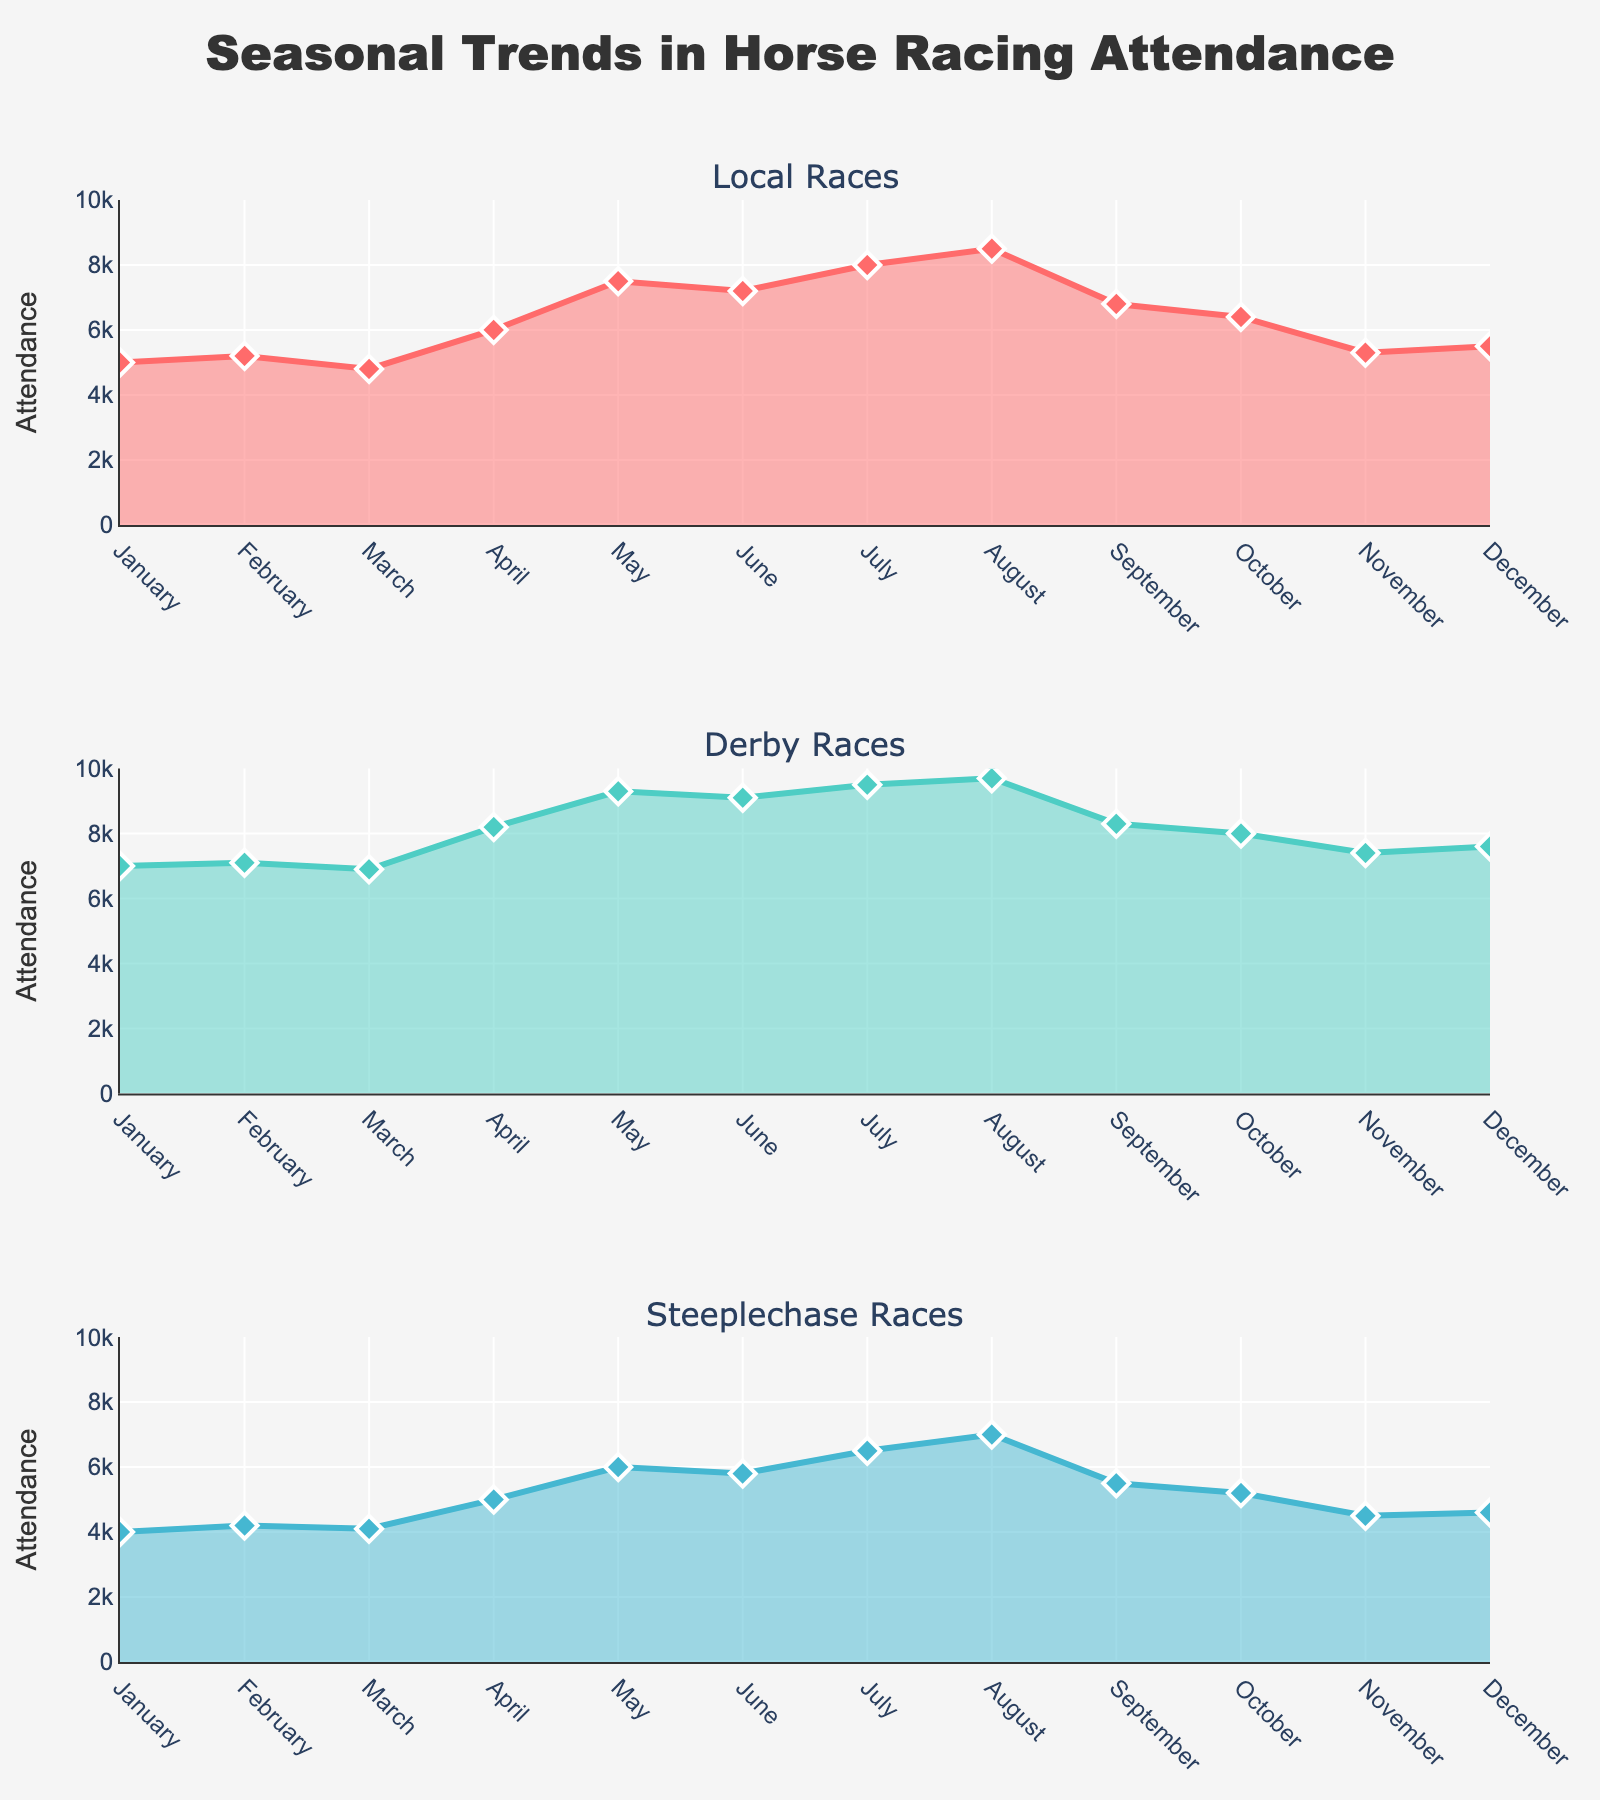What is the highest attendance recorded for Local Races, and when did it occur? By observing the topmost point of the area chart for Local Races, we can see that the peak attendance is in August with an attendance of 8500.
Answer: 8500, August What is the overall trend in attendance for Derby Races throughout the year? By looking at the line for Derby Races, we see that the attendance starts at 7000 in January, peaks at 9700 in August, then slowly declines towards the end of the year finishing at 7600 in December. This indicates an upward trend till August followed by a downward trend.
Answer: Upward till August, then downward Which month shows the lowest attendance for Steeplechase Races? By identifying the trough in the area chart for Steeplechase Races, we see that the lowest attendance is in January with 4000 attendees.
Answer: January, 4000 In which month is the attendance for Local Races and Steeplechase Races both higher than Derby Races? By comparing the attendance values for all three types of races across each month, we can see that in April, Local Races (6000) and Steeplechase Races (5000) both have higher attendances than Derby Races (8200).
Answer: April What is the average attendance for Derby Races over the year? Summing up the monthly attendance figures for Derby Races: 7000 + 7100 + 6900 + 8200 + 9300 + 9100 + 9500 + 9700 + 8300 + 8000 + 7400 + 7600 = 94100. The average is 94100 / 12 = 7841.67.
Answer: 7841.67 By how much does the attendance for Steeplechase Races increase from January to May? Subtract the attendance in January (4000) from the attendance in May (6000): 6000 - 4000 = 2000.
Answer: 2000 Compare the attendance in June for all three event types. Which event has the highest attendance and which has the lowest attendance? Comparing the June figures: Local Races (7200), Derby Races (9100), and Steeplechase Races (5800). Derby Races have the highest attendance, and Steeplechase Races have the lowest.
Answer: Derby Races highest, Steeplechase Races lowest How does the attendance in September for Local Races compare to October's attendance? The attendance for Local Races in September is 6800, while in October, it is 6400. By comparing the two, attendance in September is higher by 400.
Answer: 400 higher in September Identify the consistent trend for Derby Races from November to December. What is observed? Observing the area chart for Derby Races, from November (7400) to December (7600), there is an upward trend in attendance.
Answer: Upward trend What is the total attendance for Local Races over the entire year? Summing the monthly attendance for Local Races: 5000 + 5200 + 4800 + 6000 + 7500 + 7200 + 8000 + 8500 + 6800 + 6400 + 5300 + 5500 = 84200.
Answer: 84200 